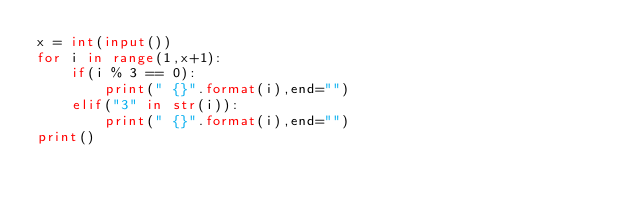<code> <loc_0><loc_0><loc_500><loc_500><_Python_>x = int(input())
for i in range(1,x+1):
    if(i % 3 == 0):
        print(" {}".format(i),end="")
    elif("3" in str(i)):
        print(" {}".format(i),end="")
print()
</code> 